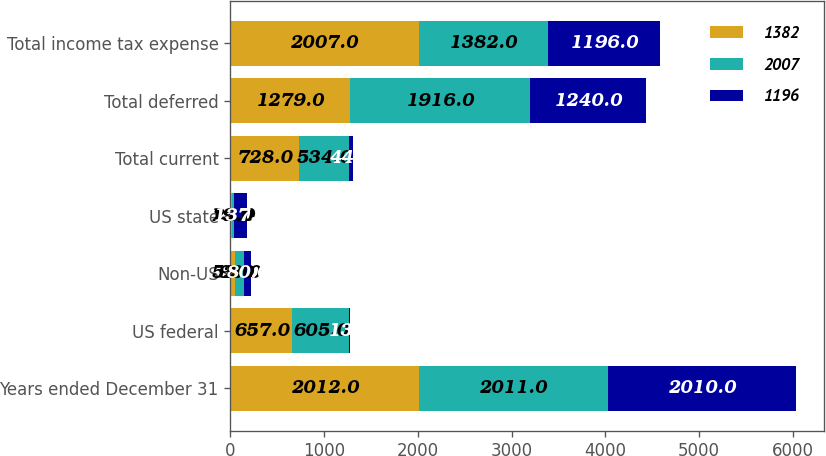Convert chart to OTSL. <chart><loc_0><loc_0><loc_500><loc_500><stacked_bar_chart><ecel><fcel>Years ended December 31<fcel>US federal<fcel>Non-US<fcel>US state<fcel>Total current<fcel>Total deferred<fcel>Total income tax expense<nl><fcel>1382<fcel>2012<fcel>657<fcel>52<fcel>19<fcel>728<fcel>1279<fcel>2007<nl><fcel>2007<fcel>2011<fcel>605<fcel>93<fcel>22<fcel>534<fcel>1916<fcel>1382<nl><fcel>1196<fcel>2010<fcel>13<fcel>80<fcel>137<fcel>44<fcel>1240<fcel>1196<nl></chart> 